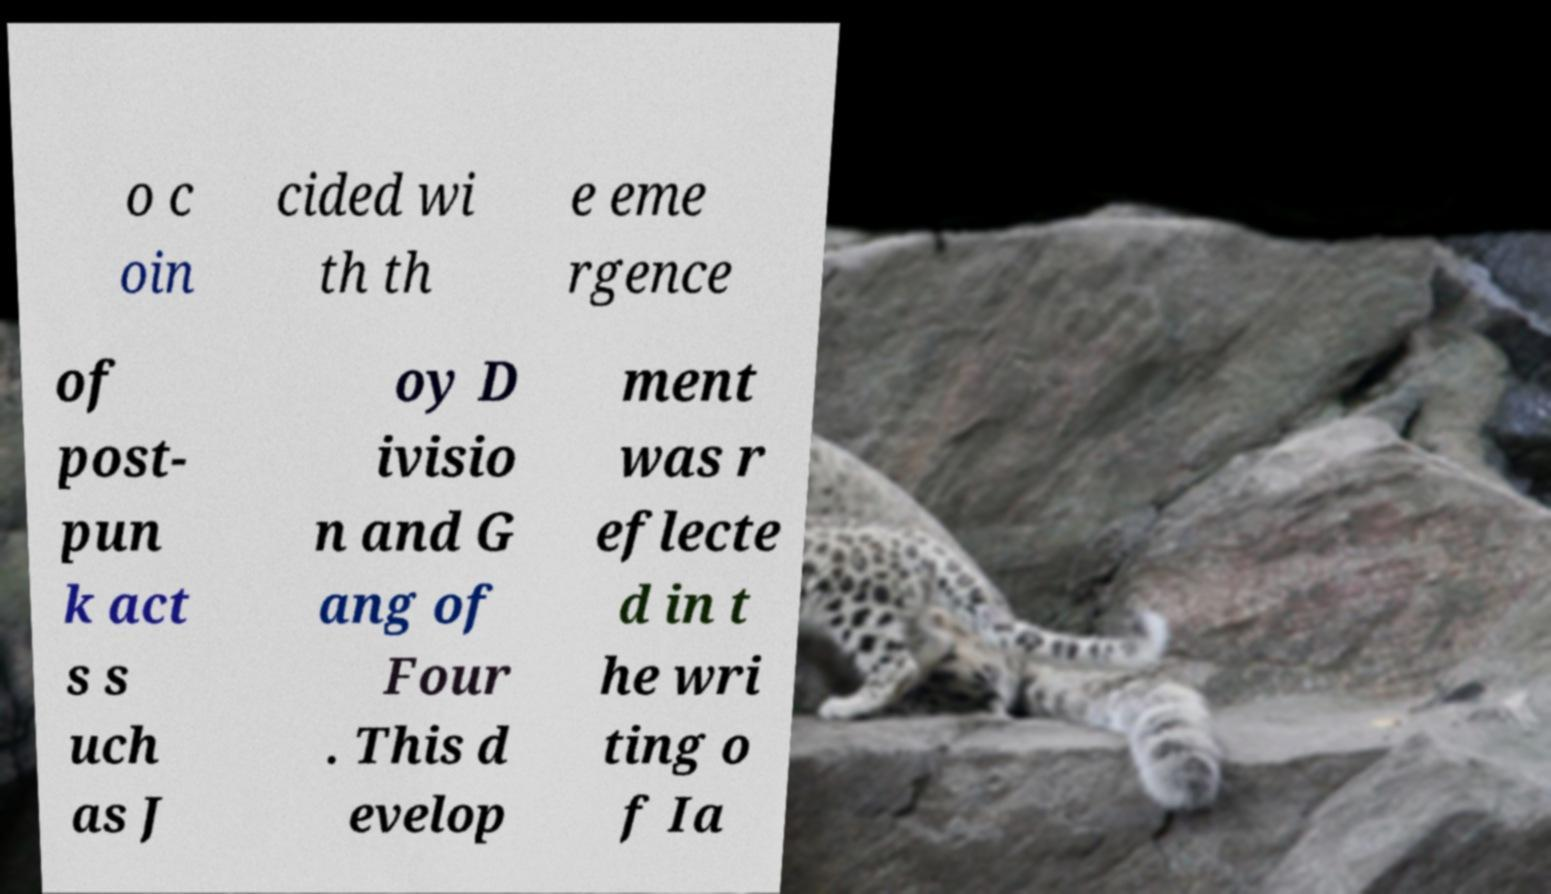Can you read and provide the text displayed in the image?This photo seems to have some interesting text. Can you extract and type it out for me? o c oin cided wi th th e eme rgence of post- pun k act s s uch as J oy D ivisio n and G ang of Four . This d evelop ment was r eflecte d in t he wri ting o f Ia 